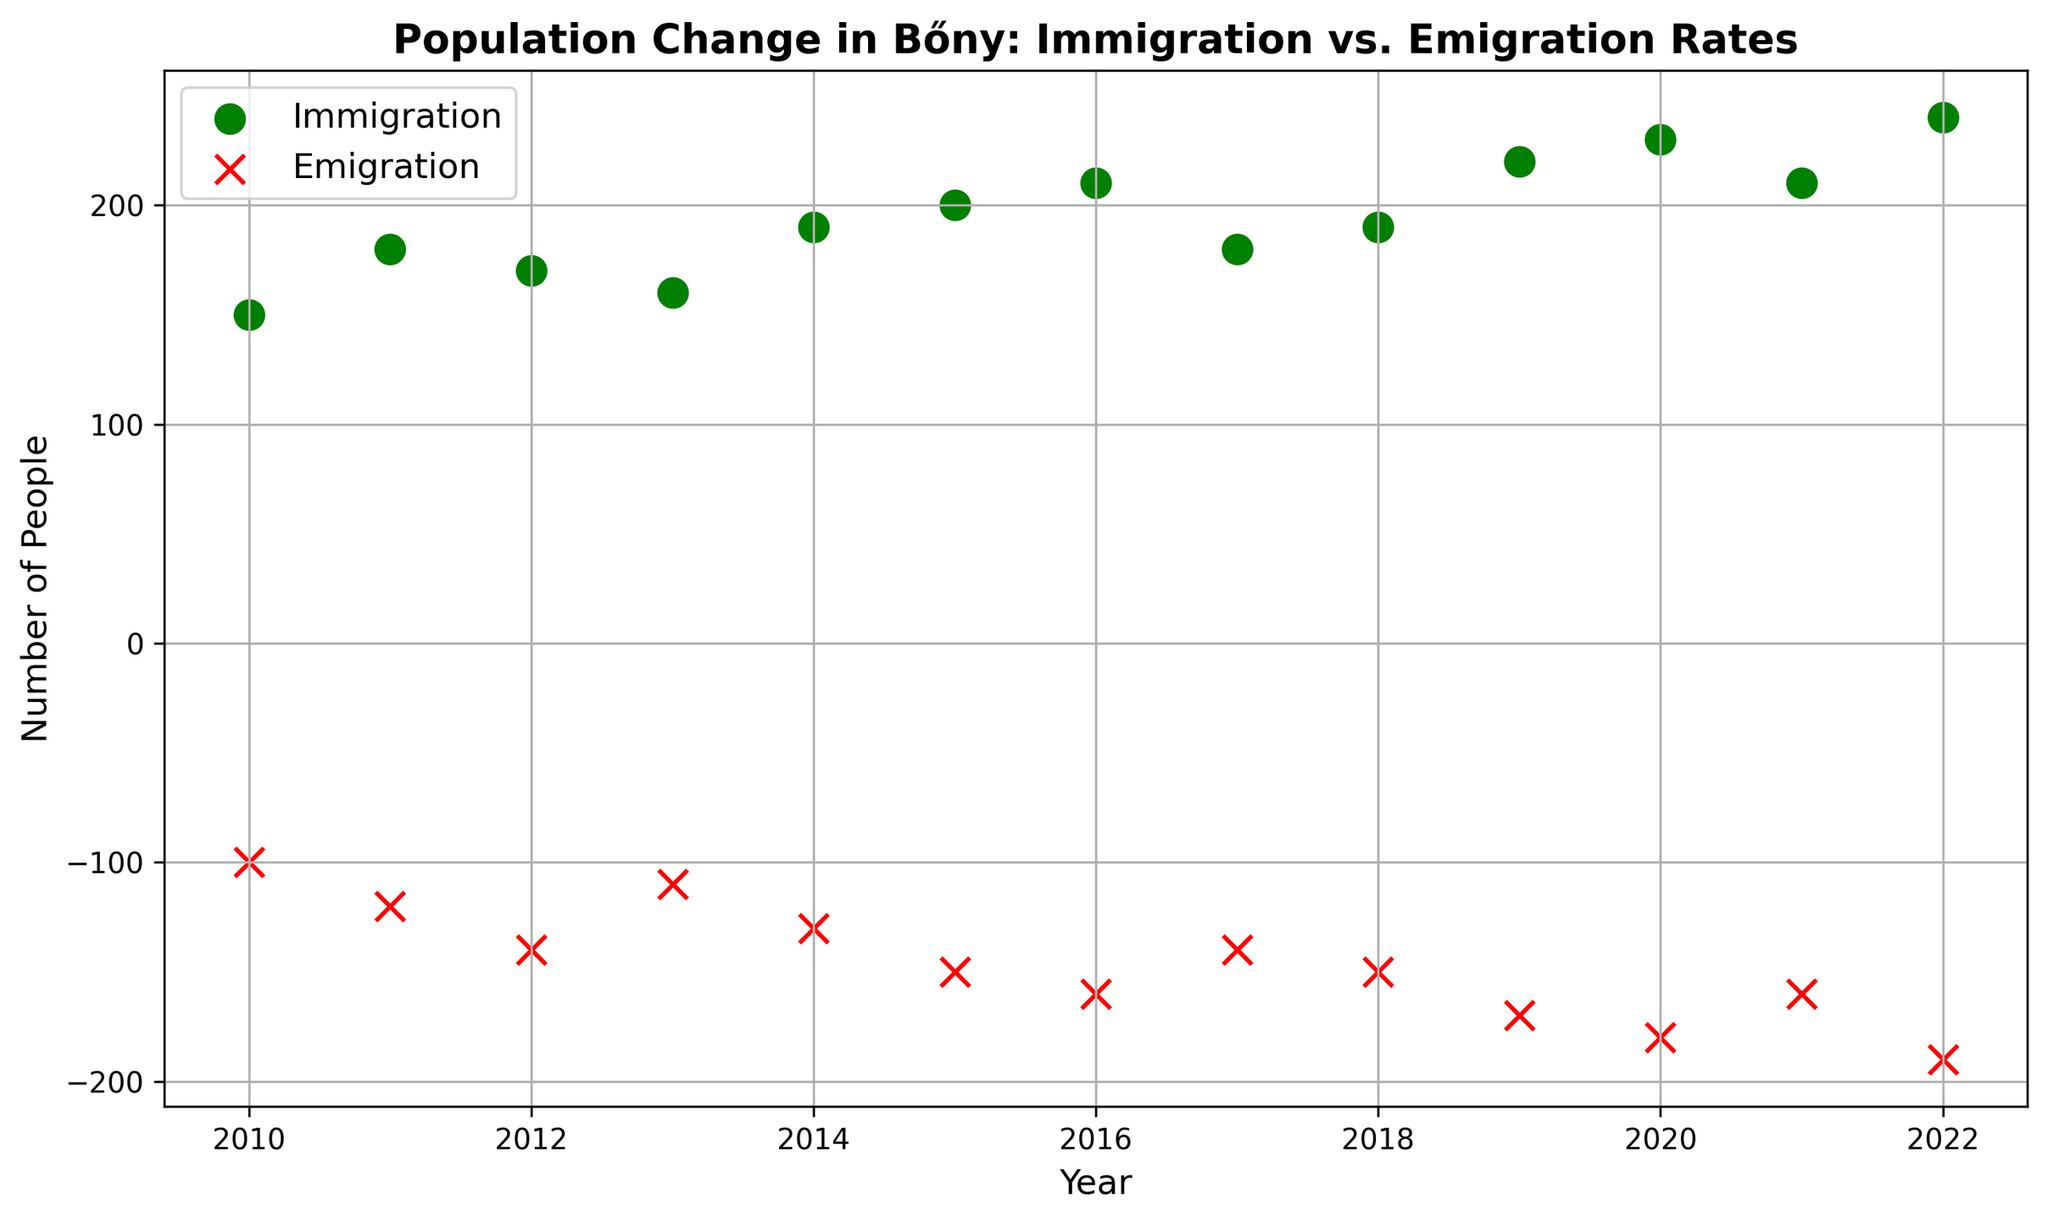Which year had the highest immigration rate? The figure shows immigration rates as green circles. The highest point appears in the year 2022 with an immigration rate of 240.
Answer: 2022 How do the immigration and emigration rates in 2017 compare? Look at the scatter plot points for 2017. The immigration rate is 180 and the emigration rate is -140.
Answer: Immigration is 180; Emigration is -140 What's the average immigration rate from 2010 to 2015? Add immigration rates from 2010 to 2015: \(150 + 180 + 170 + 160 + 190 + 200 = 1050\). There are 6 years, so the average is \(1050 / 6\).
Answer: 175 Is there a year when the immigration and emigration rates are equal? Both scatter plot series are never at the same y-value.
Answer: No Which year shows the smallest gap between immigration and emigration rates? Calculate the differences and identify the smallest. For 2010, the gap is \(150 - (-100) = 250\). Continue for each year and find that the smallest gap is in 2017: \(180 - (-140) = 320\).
Answer: 2017 How did the immigration and emigration rates trend from 2019 to 2022? Look at yearly values from 2019 to 2022. Immigration increases from 220 to 240, and emigration increases from -170 to -190.
Answer: Both increased What's the median value of emigration rates from 2010 to 2022? Order emigration rates: -100, -110, -120, -130, -140, -140, -150, -150, -160, -160, -170, -180, -190. There are 13 data points, so the median is the 7th value in the sorted list, which is -150.
Answer: -150 Which year had the largest immigration rate difference compared to the previous year? Find yearly differences: 2011 (\(180-150 = 30\)), 2012 (\(170-180 = -10\)), 2013 (\(160-170 = -10\)), 2014 (\(190-160 = 30\)), 2015 (\(200-190 = 10\)), 2016 (\(210-200 = 10\)), etc. The largest change is 40 between 2019 (220) and 2020 (230).
Answer: Between 2019 and 2020 